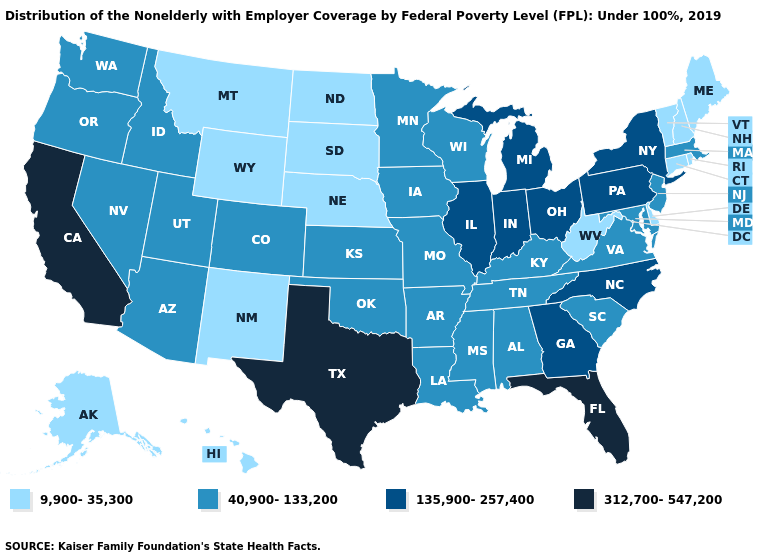What is the value of Louisiana?
Write a very short answer. 40,900-133,200. Name the states that have a value in the range 312,700-547,200?
Be succinct. California, Florida, Texas. What is the value of Vermont?
Quick response, please. 9,900-35,300. Which states have the highest value in the USA?
Write a very short answer. California, Florida, Texas. Name the states that have a value in the range 40,900-133,200?
Answer briefly. Alabama, Arizona, Arkansas, Colorado, Idaho, Iowa, Kansas, Kentucky, Louisiana, Maryland, Massachusetts, Minnesota, Mississippi, Missouri, Nevada, New Jersey, Oklahoma, Oregon, South Carolina, Tennessee, Utah, Virginia, Washington, Wisconsin. What is the value of Texas?
Write a very short answer. 312,700-547,200. What is the lowest value in states that border Connecticut?
Keep it brief. 9,900-35,300. Does the map have missing data?
Keep it brief. No. Does West Virginia have the highest value in the USA?
Be succinct. No. What is the value of Ohio?
Answer briefly. 135,900-257,400. What is the lowest value in the USA?
Concise answer only. 9,900-35,300. What is the value of Idaho?
Give a very brief answer. 40,900-133,200. Does Indiana have the same value as Wisconsin?
Concise answer only. No. Among the states that border Wisconsin , which have the highest value?
Give a very brief answer. Illinois, Michigan. What is the value of North Dakota?
Give a very brief answer. 9,900-35,300. 